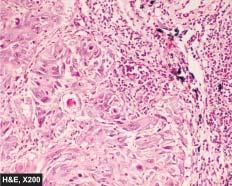re islands of invading malignant squamous cells seen?
Answer the question using a single word or phrase. Yes 